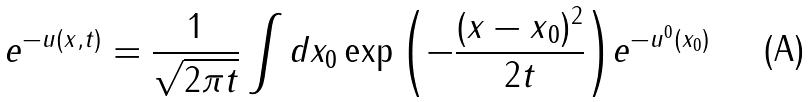<formula> <loc_0><loc_0><loc_500><loc_500>e ^ { - u ( x , t ) } = \frac { 1 } { \sqrt { 2 \pi t } } \int d x _ { 0 } \exp { \left ( - \frac { ( { x - x } _ { 0 } ) ^ { 2 } } { 2 t } \right ) } e ^ { - u ^ { 0 } ( x _ { 0 } ) }</formula> 